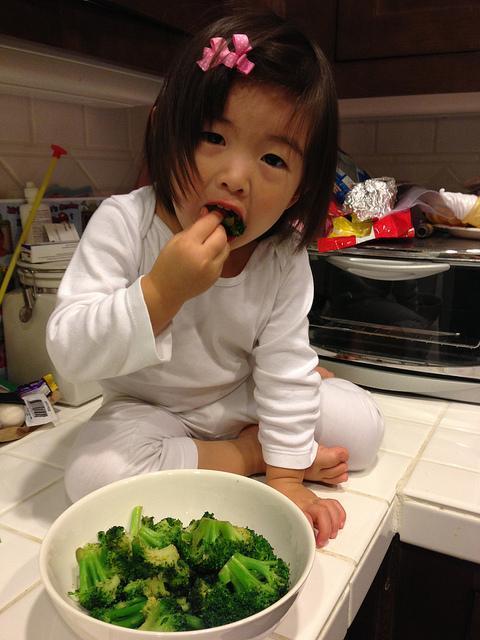How many open umbrellas are in the scene?
Give a very brief answer. 0. 